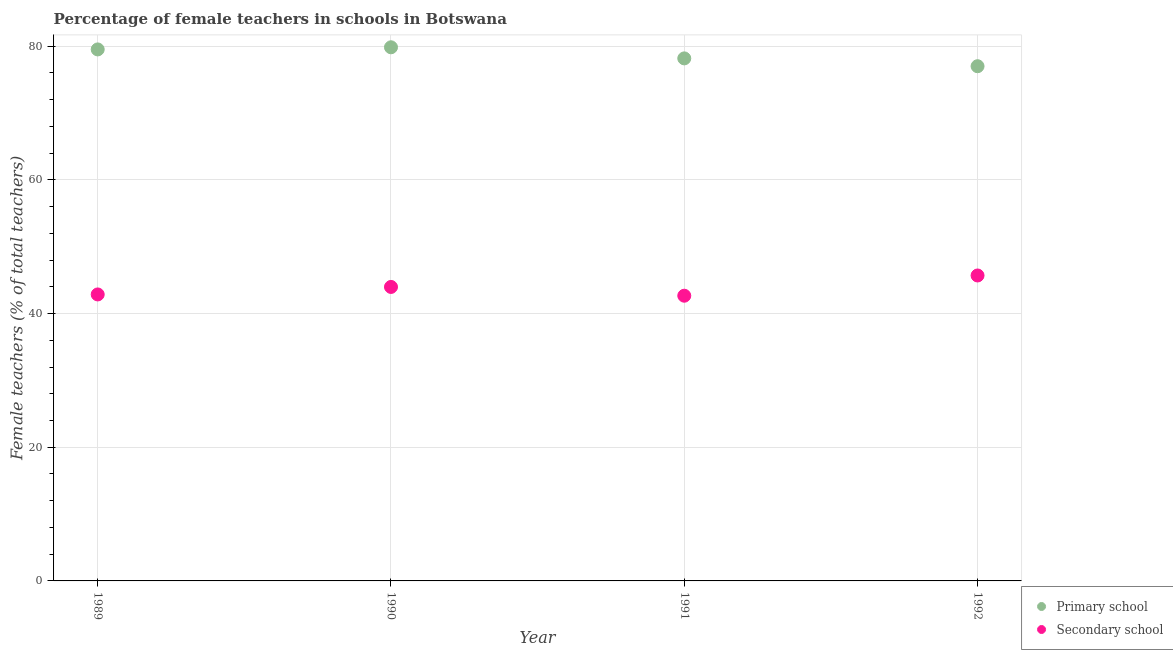How many different coloured dotlines are there?
Provide a short and direct response. 2. Is the number of dotlines equal to the number of legend labels?
Your answer should be compact. Yes. What is the percentage of female teachers in primary schools in 1990?
Offer a terse response. 79.83. Across all years, what is the maximum percentage of female teachers in primary schools?
Your answer should be compact. 79.83. Across all years, what is the minimum percentage of female teachers in secondary schools?
Make the answer very short. 42.67. In which year was the percentage of female teachers in primary schools maximum?
Offer a terse response. 1990. What is the total percentage of female teachers in secondary schools in the graph?
Provide a short and direct response. 175.21. What is the difference between the percentage of female teachers in secondary schools in 1990 and that in 1991?
Your answer should be compact. 1.31. What is the difference between the percentage of female teachers in secondary schools in 1989 and the percentage of female teachers in primary schools in 1991?
Your answer should be compact. -35.32. What is the average percentage of female teachers in primary schools per year?
Offer a very short reply. 78.63. In the year 1990, what is the difference between the percentage of female teachers in secondary schools and percentage of female teachers in primary schools?
Give a very brief answer. -35.85. What is the ratio of the percentage of female teachers in secondary schools in 1989 to that in 1991?
Offer a terse response. 1. Is the percentage of female teachers in secondary schools in 1989 less than that in 1991?
Your answer should be compact. No. Is the difference between the percentage of female teachers in secondary schools in 1989 and 1991 greater than the difference between the percentage of female teachers in primary schools in 1989 and 1991?
Give a very brief answer. No. What is the difference between the highest and the second highest percentage of female teachers in primary schools?
Provide a succinct answer. 0.32. What is the difference between the highest and the lowest percentage of female teachers in primary schools?
Provide a succinct answer. 2.83. Is the sum of the percentage of female teachers in primary schools in 1989 and 1992 greater than the maximum percentage of female teachers in secondary schools across all years?
Provide a succinct answer. Yes. Does the percentage of female teachers in primary schools monotonically increase over the years?
Provide a short and direct response. No. Is the percentage of female teachers in secondary schools strictly greater than the percentage of female teachers in primary schools over the years?
Keep it short and to the point. No. How many dotlines are there?
Your answer should be very brief. 2. How many years are there in the graph?
Make the answer very short. 4. What is the difference between two consecutive major ticks on the Y-axis?
Your answer should be very brief. 20. Does the graph contain any zero values?
Offer a terse response. No. Does the graph contain grids?
Ensure brevity in your answer.  Yes. Where does the legend appear in the graph?
Offer a very short reply. Bottom right. How many legend labels are there?
Give a very brief answer. 2. How are the legend labels stacked?
Your response must be concise. Vertical. What is the title of the graph?
Provide a short and direct response. Percentage of female teachers in schools in Botswana. What is the label or title of the Y-axis?
Provide a short and direct response. Female teachers (% of total teachers). What is the Female teachers (% of total teachers) in Primary school in 1989?
Your response must be concise. 79.52. What is the Female teachers (% of total teachers) in Secondary school in 1989?
Make the answer very short. 42.86. What is the Female teachers (% of total teachers) in Primary school in 1990?
Keep it short and to the point. 79.83. What is the Female teachers (% of total teachers) in Secondary school in 1990?
Your answer should be very brief. 43.98. What is the Female teachers (% of total teachers) in Primary school in 1991?
Ensure brevity in your answer.  78.18. What is the Female teachers (% of total teachers) of Secondary school in 1991?
Provide a short and direct response. 42.67. What is the Female teachers (% of total teachers) in Primary school in 1992?
Offer a very short reply. 77. What is the Female teachers (% of total teachers) of Secondary school in 1992?
Your response must be concise. 45.7. Across all years, what is the maximum Female teachers (% of total teachers) in Primary school?
Give a very brief answer. 79.83. Across all years, what is the maximum Female teachers (% of total teachers) of Secondary school?
Offer a very short reply. 45.7. Across all years, what is the minimum Female teachers (% of total teachers) in Primary school?
Your response must be concise. 77. Across all years, what is the minimum Female teachers (% of total teachers) of Secondary school?
Your answer should be compact. 42.67. What is the total Female teachers (% of total teachers) of Primary school in the graph?
Keep it short and to the point. 314.53. What is the total Female teachers (% of total teachers) in Secondary school in the graph?
Ensure brevity in your answer.  175.21. What is the difference between the Female teachers (% of total teachers) in Primary school in 1989 and that in 1990?
Offer a terse response. -0.32. What is the difference between the Female teachers (% of total teachers) in Secondary school in 1989 and that in 1990?
Your answer should be compact. -1.12. What is the difference between the Female teachers (% of total teachers) in Primary school in 1989 and that in 1991?
Offer a terse response. 1.34. What is the difference between the Female teachers (% of total teachers) of Secondary school in 1989 and that in 1991?
Your answer should be very brief. 0.19. What is the difference between the Female teachers (% of total teachers) in Primary school in 1989 and that in 1992?
Your answer should be compact. 2.51. What is the difference between the Female teachers (% of total teachers) of Secondary school in 1989 and that in 1992?
Your response must be concise. -2.84. What is the difference between the Female teachers (% of total teachers) in Primary school in 1990 and that in 1991?
Ensure brevity in your answer.  1.66. What is the difference between the Female teachers (% of total teachers) in Secondary school in 1990 and that in 1991?
Your response must be concise. 1.31. What is the difference between the Female teachers (% of total teachers) of Primary school in 1990 and that in 1992?
Ensure brevity in your answer.  2.83. What is the difference between the Female teachers (% of total teachers) in Secondary school in 1990 and that in 1992?
Your answer should be very brief. -1.71. What is the difference between the Female teachers (% of total teachers) of Primary school in 1991 and that in 1992?
Give a very brief answer. 1.17. What is the difference between the Female teachers (% of total teachers) in Secondary school in 1991 and that in 1992?
Offer a terse response. -3.03. What is the difference between the Female teachers (% of total teachers) in Primary school in 1989 and the Female teachers (% of total teachers) in Secondary school in 1990?
Keep it short and to the point. 35.54. What is the difference between the Female teachers (% of total teachers) in Primary school in 1989 and the Female teachers (% of total teachers) in Secondary school in 1991?
Ensure brevity in your answer.  36.85. What is the difference between the Female teachers (% of total teachers) in Primary school in 1989 and the Female teachers (% of total teachers) in Secondary school in 1992?
Give a very brief answer. 33.82. What is the difference between the Female teachers (% of total teachers) in Primary school in 1990 and the Female teachers (% of total teachers) in Secondary school in 1991?
Ensure brevity in your answer.  37.17. What is the difference between the Female teachers (% of total teachers) of Primary school in 1990 and the Female teachers (% of total teachers) of Secondary school in 1992?
Make the answer very short. 34.14. What is the difference between the Female teachers (% of total teachers) in Primary school in 1991 and the Female teachers (% of total teachers) in Secondary school in 1992?
Make the answer very short. 32.48. What is the average Female teachers (% of total teachers) in Primary school per year?
Provide a short and direct response. 78.63. What is the average Female teachers (% of total teachers) in Secondary school per year?
Make the answer very short. 43.8. In the year 1989, what is the difference between the Female teachers (% of total teachers) in Primary school and Female teachers (% of total teachers) in Secondary school?
Provide a succinct answer. 36.66. In the year 1990, what is the difference between the Female teachers (% of total teachers) in Primary school and Female teachers (% of total teachers) in Secondary school?
Your answer should be very brief. 35.85. In the year 1991, what is the difference between the Female teachers (% of total teachers) of Primary school and Female teachers (% of total teachers) of Secondary school?
Give a very brief answer. 35.51. In the year 1992, what is the difference between the Female teachers (% of total teachers) in Primary school and Female teachers (% of total teachers) in Secondary school?
Offer a very short reply. 31.31. What is the ratio of the Female teachers (% of total teachers) of Primary school in 1989 to that in 1990?
Ensure brevity in your answer.  1. What is the ratio of the Female teachers (% of total teachers) of Secondary school in 1989 to that in 1990?
Make the answer very short. 0.97. What is the ratio of the Female teachers (% of total teachers) in Primary school in 1989 to that in 1991?
Your answer should be very brief. 1.02. What is the ratio of the Female teachers (% of total teachers) in Primary school in 1989 to that in 1992?
Your response must be concise. 1.03. What is the ratio of the Female teachers (% of total teachers) in Secondary school in 1989 to that in 1992?
Make the answer very short. 0.94. What is the ratio of the Female teachers (% of total teachers) in Primary school in 1990 to that in 1991?
Your response must be concise. 1.02. What is the ratio of the Female teachers (% of total teachers) in Secondary school in 1990 to that in 1991?
Your answer should be very brief. 1.03. What is the ratio of the Female teachers (% of total teachers) of Primary school in 1990 to that in 1992?
Offer a terse response. 1.04. What is the ratio of the Female teachers (% of total teachers) of Secondary school in 1990 to that in 1992?
Your response must be concise. 0.96. What is the ratio of the Female teachers (% of total teachers) of Primary school in 1991 to that in 1992?
Ensure brevity in your answer.  1.02. What is the ratio of the Female teachers (% of total teachers) in Secondary school in 1991 to that in 1992?
Provide a short and direct response. 0.93. What is the difference between the highest and the second highest Female teachers (% of total teachers) in Primary school?
Keep it short and to the point. 0.32. What is the difference between the highest and the second highest Female teachers (% of total teachers) of Secondary school?
Make the answer very short. 1.71. What is the difference between the highest and the lowest Female teachers (% of total teachers) in Primary school?
Provide a succinct answer. 2.83. What is the difference between the highest and the lowest Female teachers (% of total teachers) of Secondary school?
Keep it short and to the point. 3.03. 